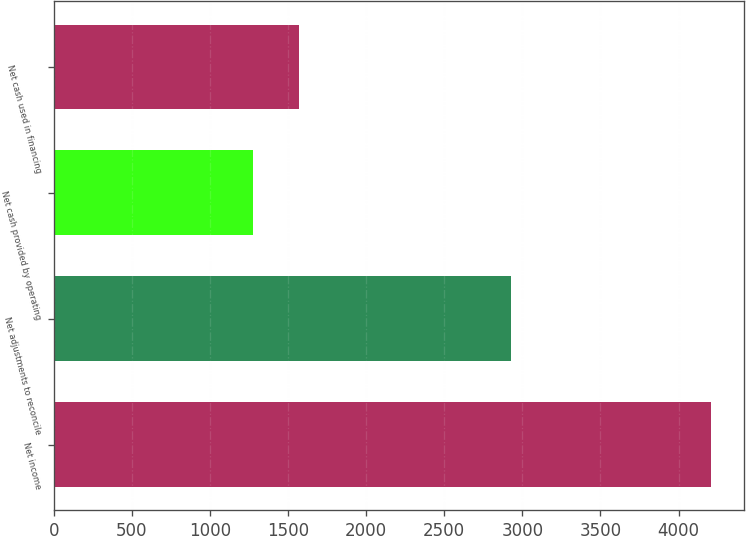Convert chart. <chart><loc_0><loc_0><loc_500><loc_500><bar_chart><fcel>Net income<fcel>Net adjustments to reconcile<fcel>Net cash provided by operating<fcel>Net cash used in financing<nl><fcel>4208<fcel>2930<fcel>1278<fcel>1571<nl></chart> 